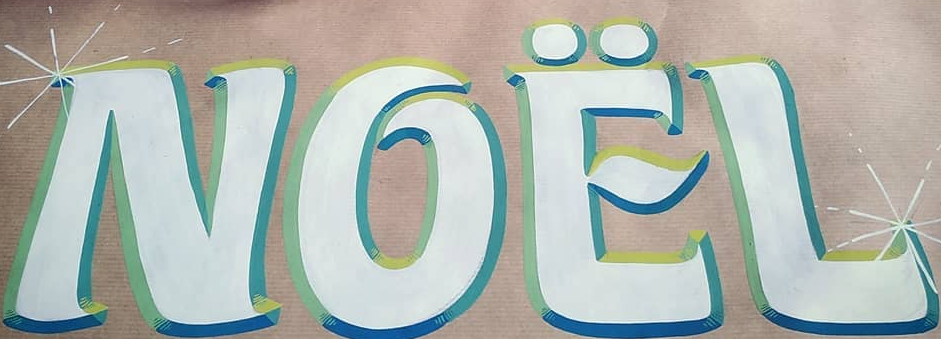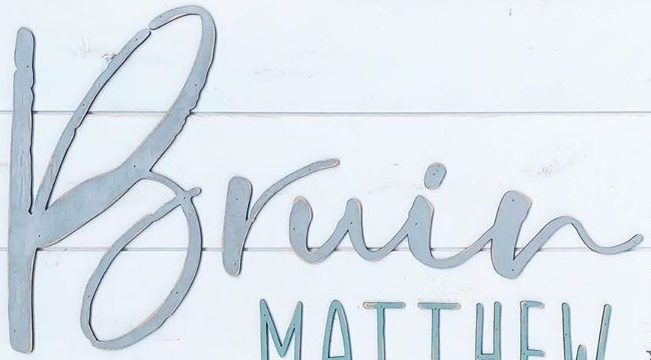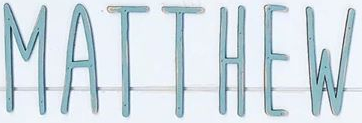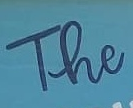Transcribe the words shown in these images in order, separated by a semicolon. NOËL; Bruin; MATTHEW; The 